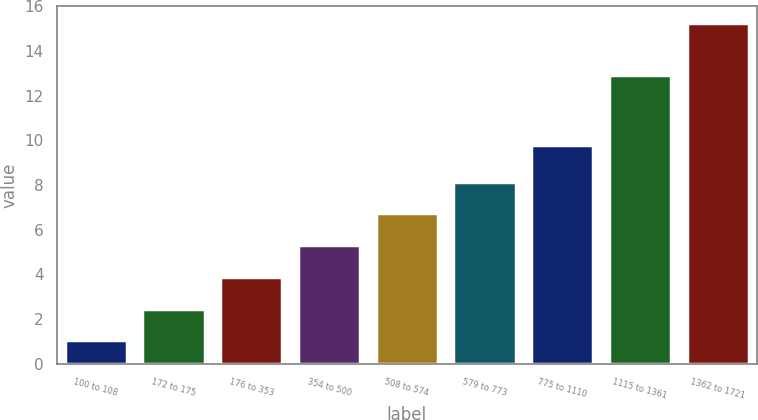Convert chart to OTSL. <chart><loc_0><loc_0><loc_500><loc_500><bar_chart><fcel>100 to 108<fcel>172 to 175<fcel>176 to 353<fcel>354 to 500<fcel>508 to 574<fcel>579 to 773<fcel>775 to 1110<fcel>1115 to 1361<fcel>1362 to 1721<nl><fcel>1.05<fcel>2.47<fcel>3.89<fcel>5.31<fcel>6.73<fcel>8.15<fcel>9.77<fcel>12.9<fcel>15.24<nl></chart> 